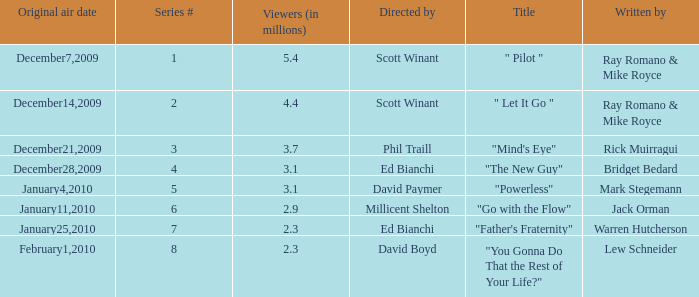What is the episode number of  "you gonna do that the rest of your life?" 8.0. 